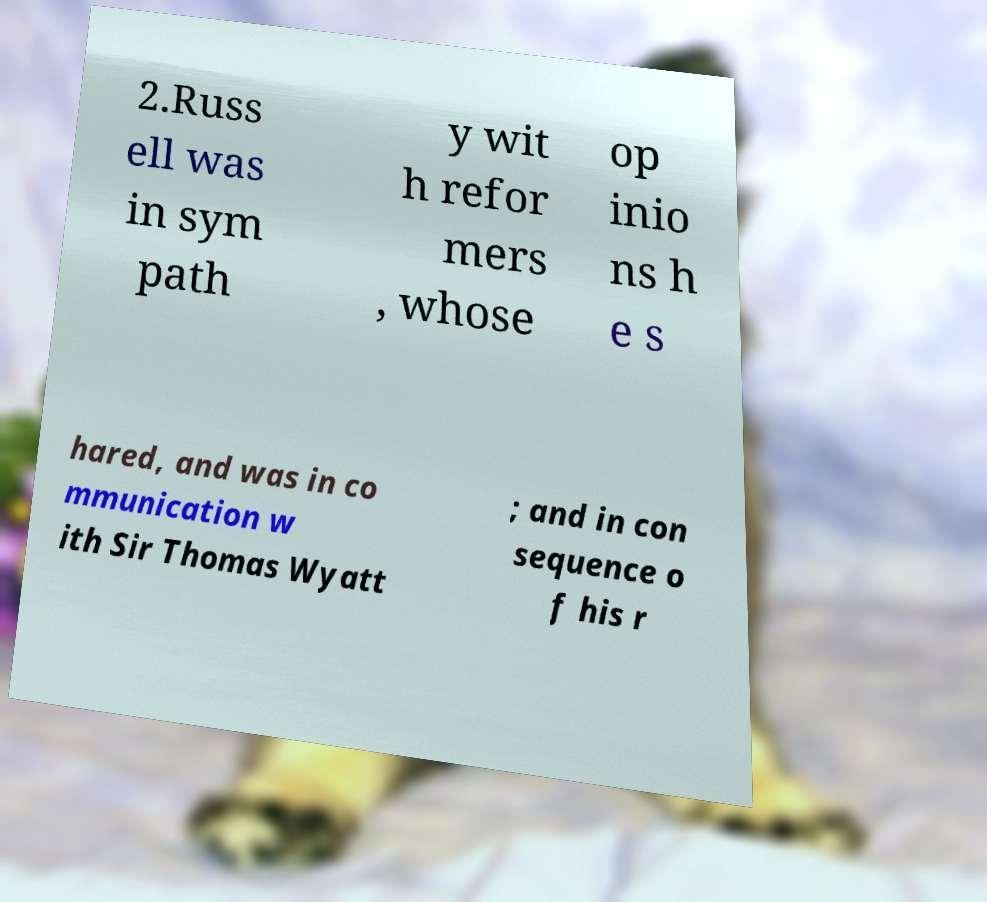There's text embedded in this image that I need extracted. Can you transcribe it verbatim? 2.Russ ell was in sym path y wit h refor mers , whose op inio ns h e s hared, and was in co mmunication w ith Sir Thomas Wyatt ; and in con sequence o f his r 